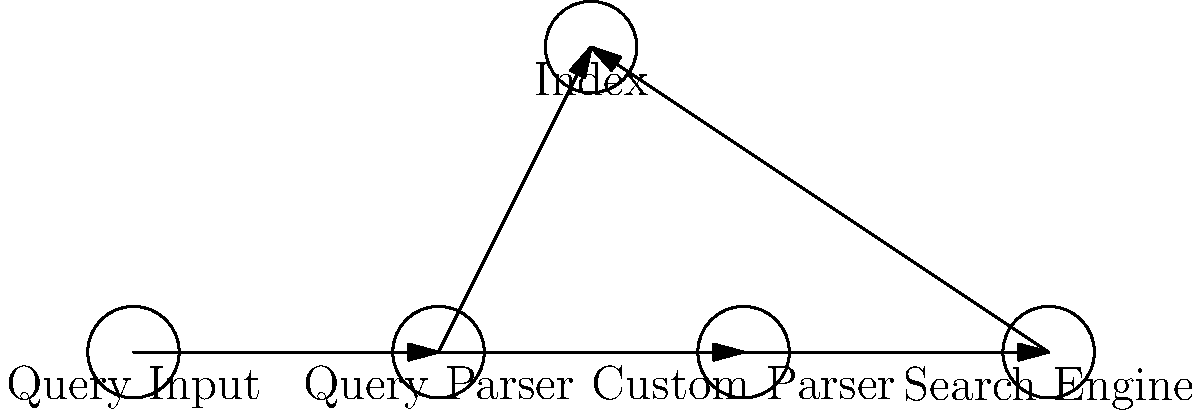In the SharePoint search query processing flow with custom parsers, which component directly interacts with both the Query Parser and the Search Engine? To answer this question, let's analyze the flow of the SharePoint search query processing with custom parsers:

1. The process starts with the Query Input, which is the user's search query.
2. The query is then passed to the Query Parser, which interprets the query syntax.
3. After the Query Parser, we see two paths:
   a. One path goes directly to the Index, which stores the searchable content.
   b. The other path goes through a Custom Parser.
4. The Custom Parser is positioned between the Query Parser and the Search Engine.
5. The Custom Parser can modify or enhance the parsed query before it reaches the Search Engine.
6. Finally, the Search Engine interacts with the Index to retrieve the relevant results.

Looking at the diagram, we can see that the Custom Parser is the component that directly interacts with both the Query Parser (receiving input from it) and the Search Engine (sending output to it). It acts as an intermediary, allowing for customized processing of the query before it reaches the Search Engine.
Answer: Custom Parser 